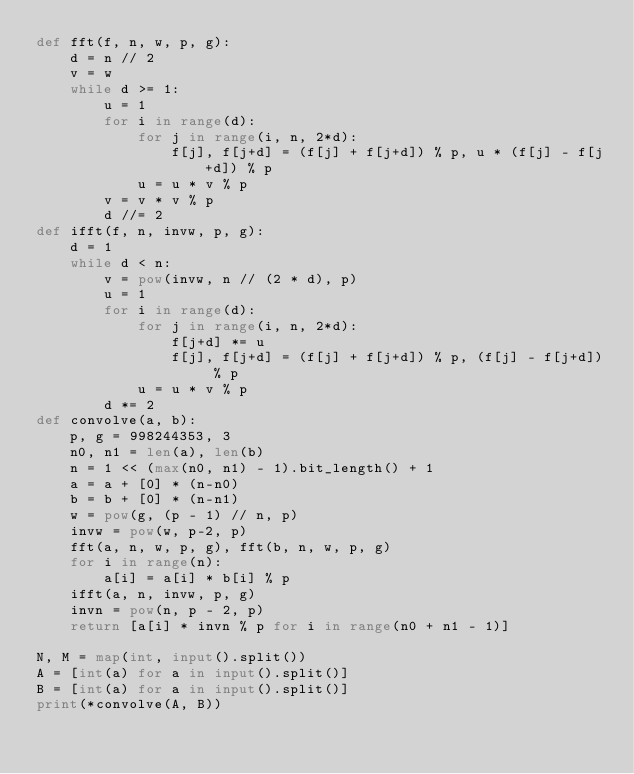Convert code to text. <code><loc_0><loc_0><loc_500><loc_500><_Python_>def fft(f, n, w, p, g):
    d = n // 2
    v = w
    while d >= 1:
        u = 1
        for i in range(d):
            for j in range(i, n, 2*d):
                f[j], f[j+d] = (f[j] + f[j+d]) % p, u * (f[j] - f[j+d]) % p
            u = u * v % p
        v = v * v % p
        d //= 2
def ifft(f, n, invw, p, g):
    d = 1
    while d < n:
        v = pow(invw, n // (2 * d), p)
        u = 1
        for i in range(d):
            for j in range(i, n, 2*d):
                f[j+d] *= u
                f[j], f[j+d] = (f[j] + f[j+d]) % p, (f[j] - f[j+d]) % p
            u = u * v % p
        d *= 2
def convolve(a, b):
    p, g = 998244353, 3
    n0, n1 = len(a), len(b)
    n = 1 << (max(n0, n1) - 1).bit_length() + 1
    a = a + [0] * (n-n0)
    b = b + [0] * (n-n1)
    w = pow(g, (p - 1) // n, p)
    invw = pow(w, p-2, p)
    fft(a, n, w, p, g), fft(b, n, w, p, g)
    for i in range(n):
        a[i] = a[i] * b[i] % p
    ifft(a, n, invw, p, g)
    invn = pow(n, p - 2, p)
    return [a[i] * invn % p for i in range(n0 + n1 - 1)]

N, M = map(int, input().split())
A = [int(a) for a in input().split()]
B = [int(a) for a in input().split()]
print(*convolve(A, B))
</code> 